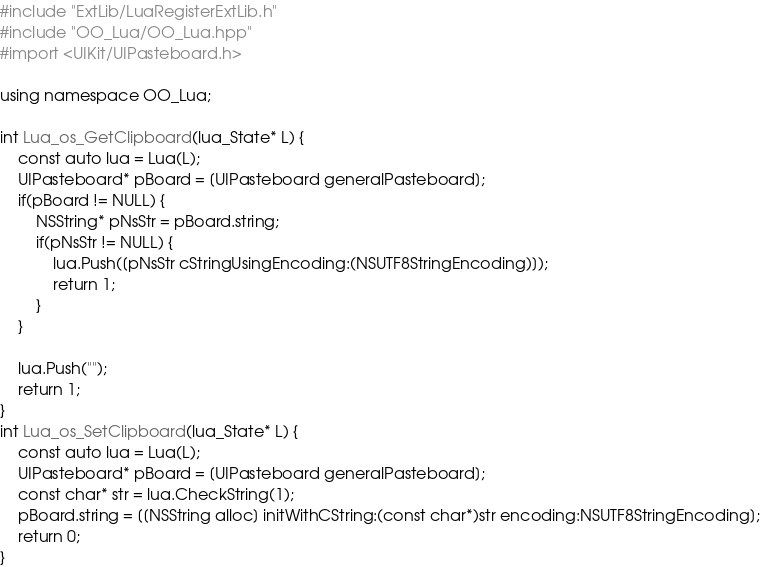Convert code to text. <code><loc_0><loc_0><loc_500><loc_500><_ObjectiveC_>#include "ExtLib/LuaRegisterExtLib.h"
#include "OO_Lua/OO_Lua.hpp"
#import <UIKit/UIPasteboard.h>

using namespace OO_Lua;

int Lua_os_GetClipboard(lua_State* L) {
    const auto lua = Lua(L);
    UIPasteboard* pBoard = [UIPasteboard generalPasteboard];
    if(pBoard != NULL) {
        NSString* pNsStr = pBoard.string;
        if(pNsStr != NULL) {
            lua.Push([pNsStr cStringUsingEncoding:(NSUTF8StringEncoding)]);
            return 1;
        }
    }

    lua.Push("");
    return 1;
}
int Lua_os_SetClipboard(lua_State* L) {
    const auto lua = Lua(L);
    UIPasteboard* pBoard = [UIPasteboard generalPasteboard];
    const char* str = lua.CheckString(1);
    pBoard.string = [[NSString alloc] initWithCString:(const char*)str encoding:NSUTF8StringEncoding];
    return 0;
}
</code> 